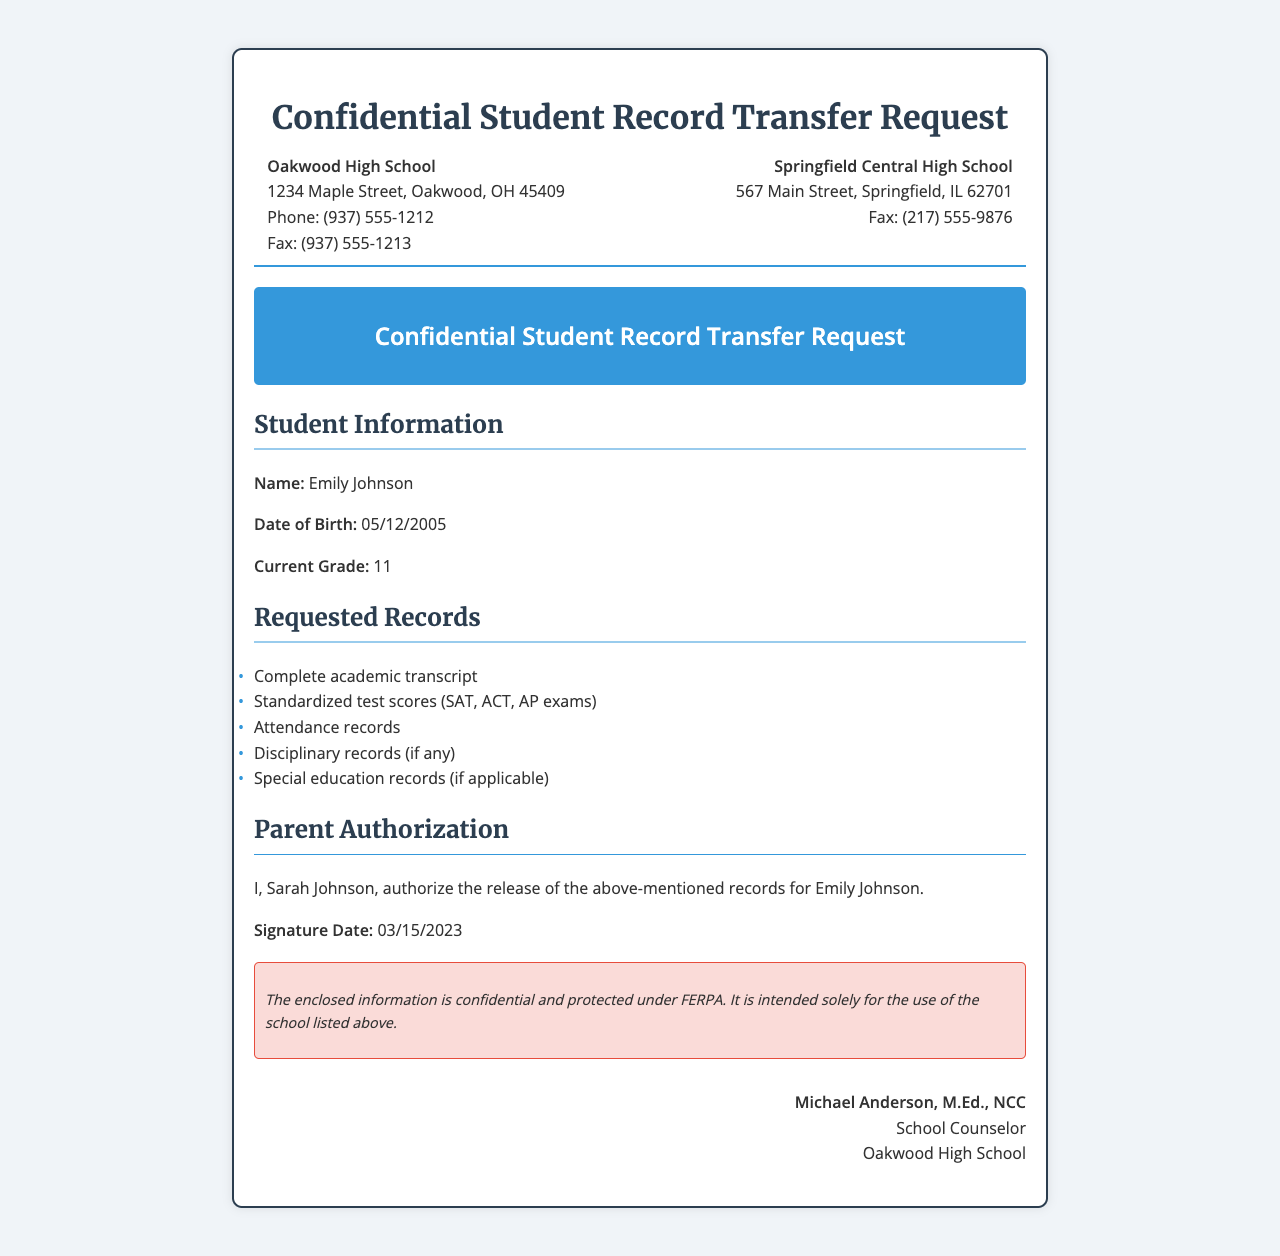What is the student's name? The student's name is explicitly mentioned in the document as Emily Johnson.
Answer: Emily Johnson What is the date of birth of the student? The date of birth is stated in the student information section as 05/12/2005.
Answer: 05/12/2005 What records were requested? The document lists the requested records, which includes a complete academic transcript and standardized test scores among others.
Answer: Complete academic transcript, standardized test scores, attendance records, disciplinary records, special education records Who authorized the release of the records? The parent of the student, Sarah Johnson, is noted as the person who authorized the records' release.
Answer: Sarah Johnson What is the fax number of Springfield Central High School? The fax number for Springfield Central High School is provided in the recipient information part of the document.
Answer: (217) 555-9876 How many standardized test types are mentioned? The document specifically mentions three types of standardized tests: SAT, ACT, and AP exams.
Answer: Three What is the counselor’s name? The name of the counselor is clearly stated at the end of the document as Michael Anderson.
Answer: Michael Anderson What is the intent of the confidentiality notice? The confidentiality notice indicates that the enclosed information is protected and intended only for the listed school.
Answer: Protected and intended solely for the use of Springfield Central High School What is the current grade of the student? The current grade of Emily Johnson is mentioned in the document as 11.
Answer: 11 